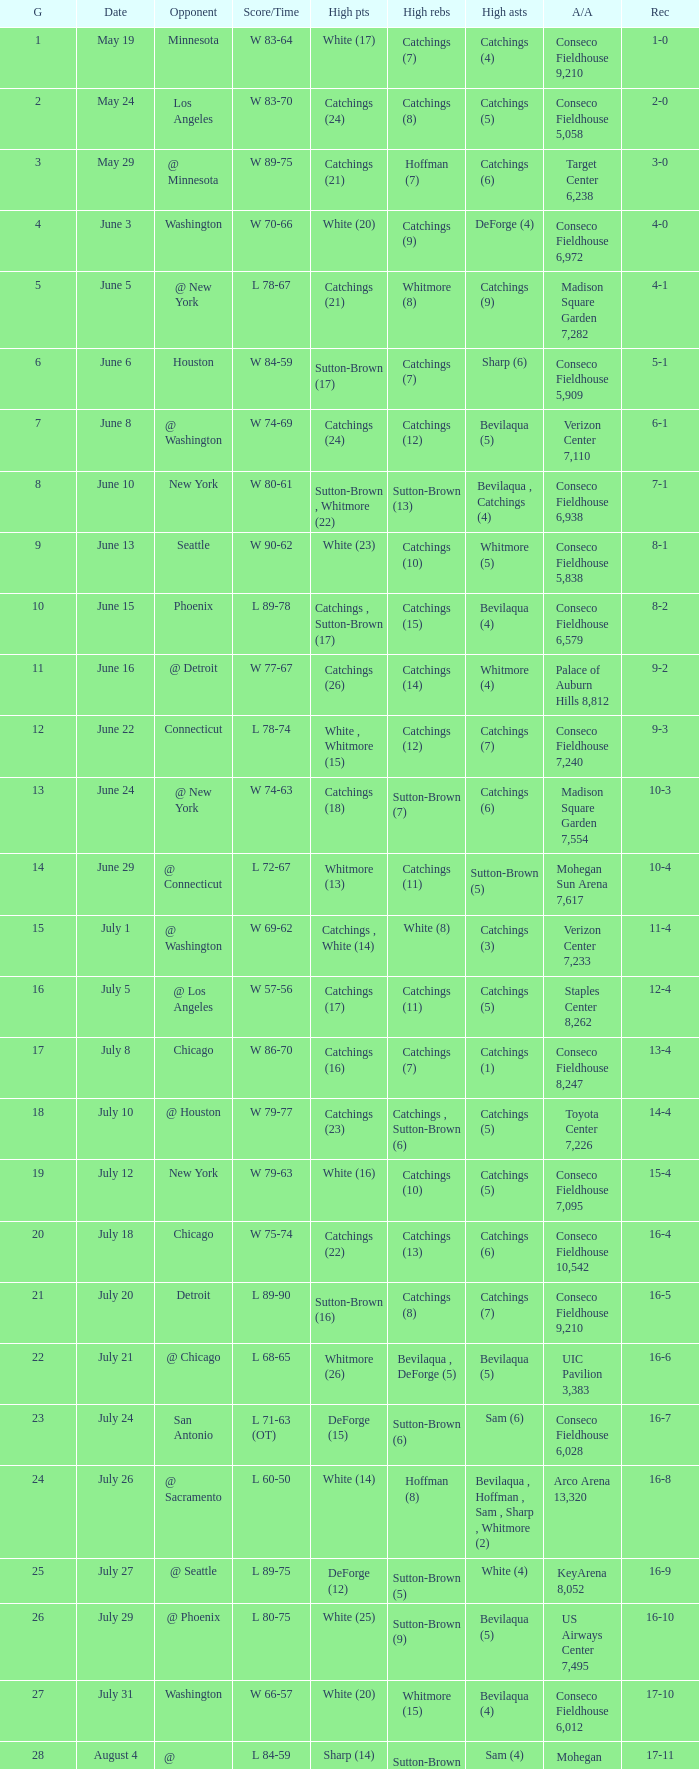Name the total number of opponent of record 9-2 1.0. 